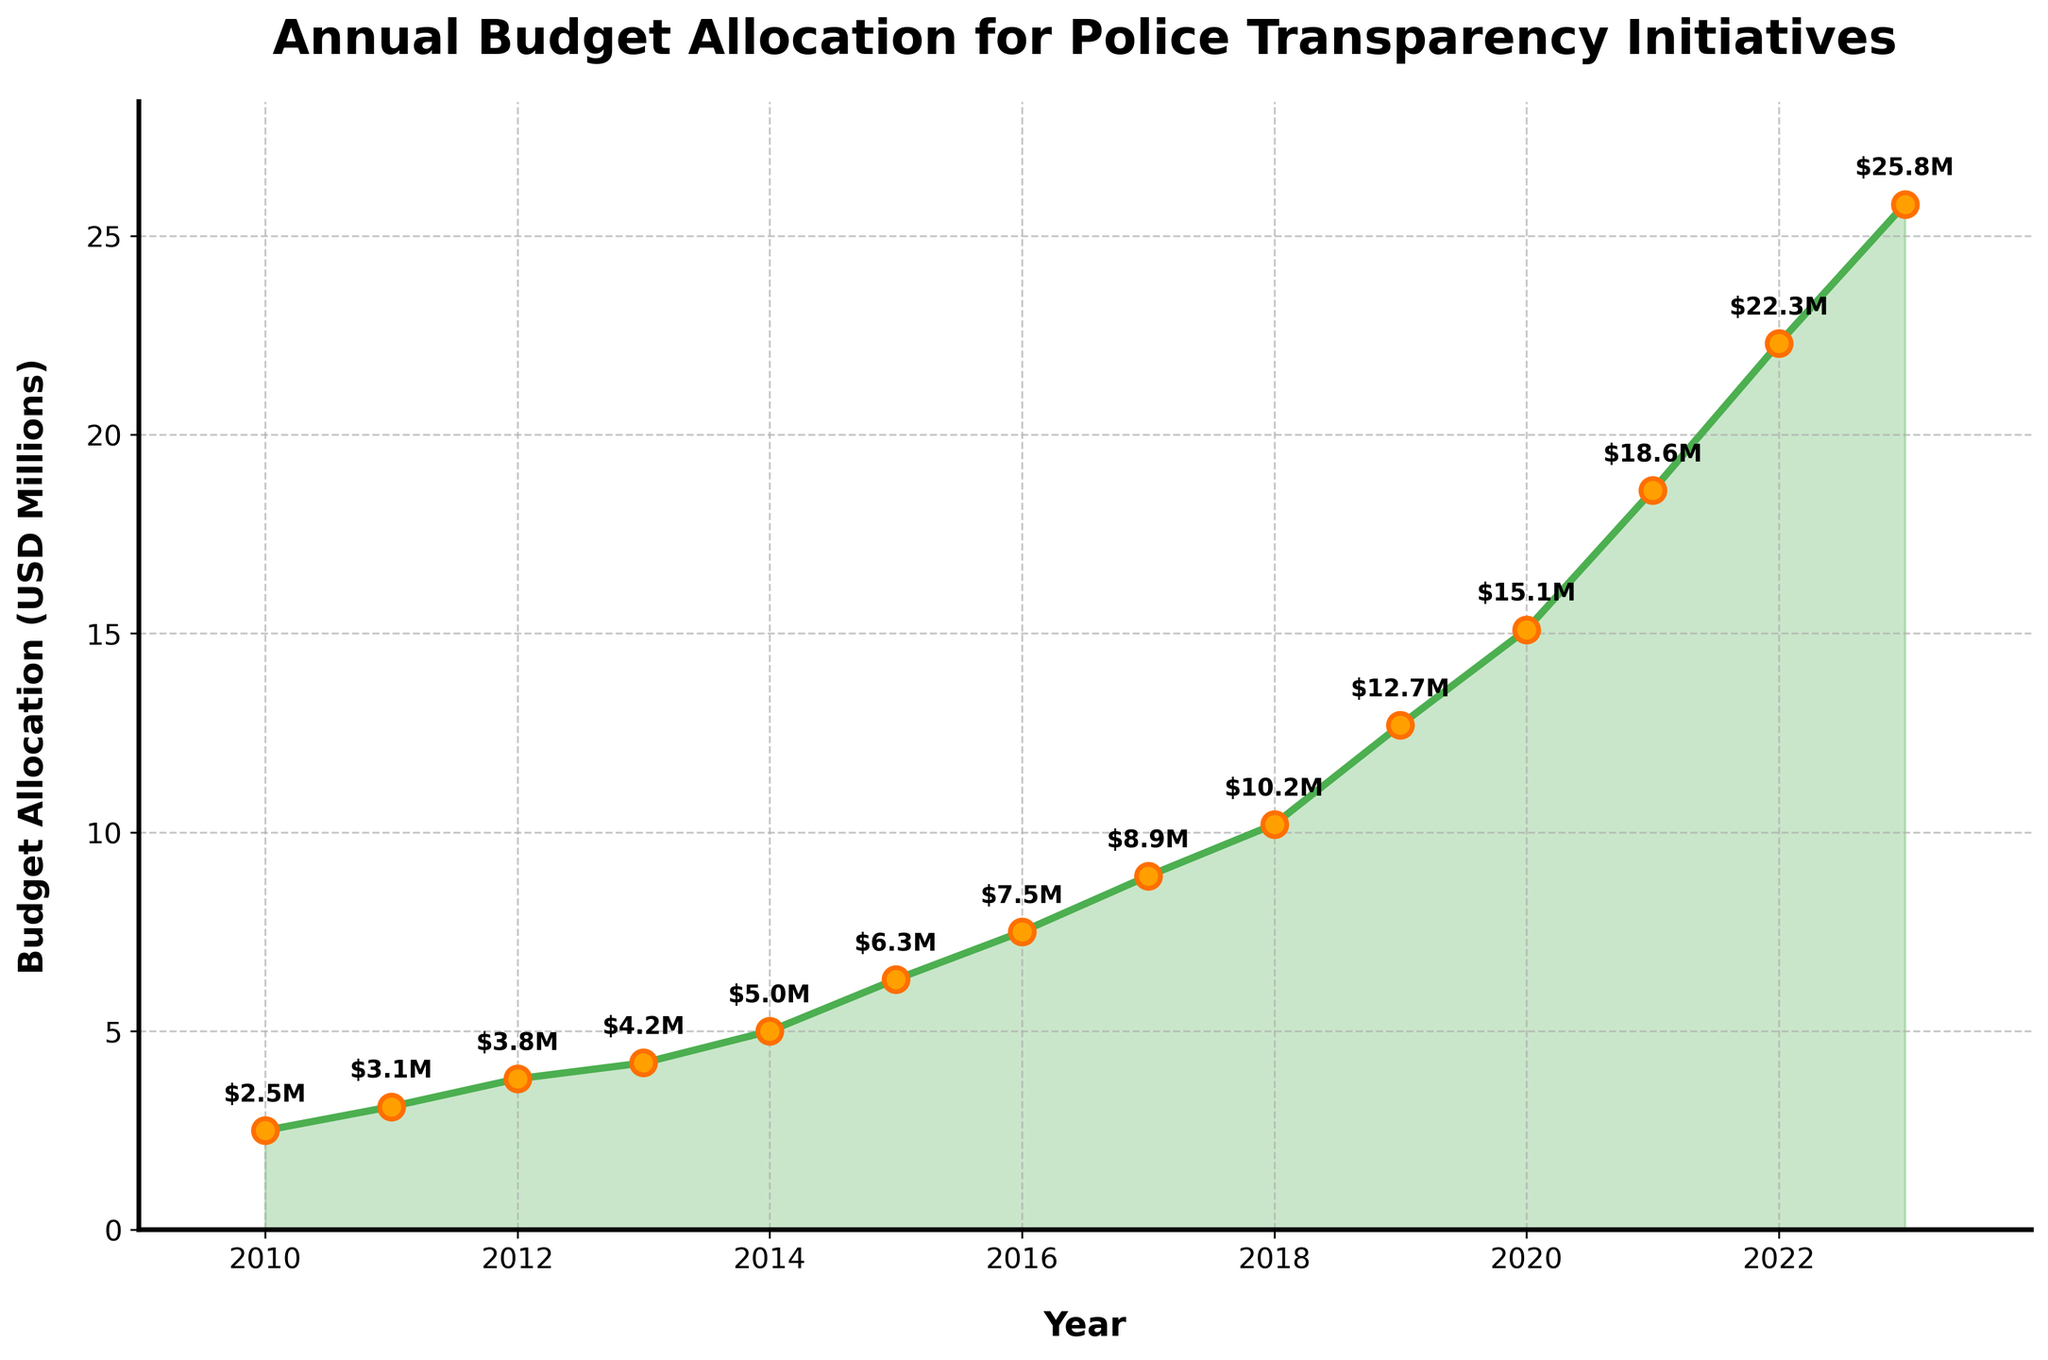what was the budget allocation for police transparency initiatives in 2010? The value can be read directly from the plot at year 2010, marked by an annotated point on the line chart
Answer: $2.5M What is the percentage increase in the budget from 2010 to 2023? First, find the budget values for 2010 and 2023, which are $2.5M and $25.8M respectively. Compute the increase ($25.8M - $2.5M = $23.3M). The percentage increase is then (23.3 / 2.5) * 100 = 932%
Answer: 932% During which year did the budget allocation first exceed $10M? Identify the point on the line chart where the budget allocation first surpasses $10M. This occurs between the years 2017 and 2018. From the annotations, it is clear that in 2018, the budget allocation is $10.2M
Answer: 2018 How much more was the budget in 2023 compared to in 2015? Find the budget values for 2023 and 2015, $25.8M and $6.3M respectively. Subtract 2015's value from 2023's value: $25.8M - $6.3M = $19.5M
Answer: $19.5M Which year experienced the largest single-year budget increase? Examine the annotated points to determine the increment between each consecutive year. Compare these differences. The largest single-year increase is observed from 2021 to 2022, where the difference is $22.3M - $18.6M = $3.7M
Answer: 2022 In which year was the budget closest to $5M? Identify the years around the $5M mark. From the chart, 2014’s budget allocation is closest to $5M at exactly $5M
Answer: 2014 Calculate the total budget allocation from 2010 to 2015. Sum the budget values from 2010 to 2015: $2.5M + $3.1M + $3.8M + $4.2M + $5.0M + $6.3M = $24.9M
Answer: $24.9M What is the average annual budget allocation for the given years? Sum all budget allocations from 2010 to 2023 and divide by the number of years. The total budget is $2.5M + $3.1M + $3.8M + $4.2M + $5.0M + $6.3M + $7.5M + $8.9M + $10.2M + $12.7M + $15.1M + $18.6M + $22.3M + $25.8M = $146M. The average is $146M / 14 ≈ $10.43M
Answer: $10.43M How does the budget allocated in 2020 compare to 2012? Compare the values from 2020 ($15.1M) and 2012 ($3.8M). The budget in 2020 is significantly higher. Specifically, $15.1M - $3.8M = $11.3M more
Answer: $11.3M more Which visual element helps to emphasize the trend in budget allocation over the years? The fill between the line plot and the x-axis using a green shade enhances the visual trend of the increasing budget allocation over the years
Answer: Shaded fill between the line plot and x-axis 